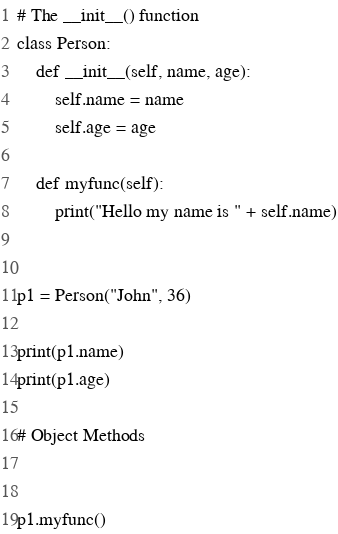<code> <loc_0><loc_0><loc_500><loc_500><_Python_># The __init__() function
class Person:
    def __init__(self, name, age):
        self.name = name
        self.age = age

    def myfunc(self):
        print("Hello my name is " + self.name)


p1 = Person("John", 36)

print(p1.name)
print(p1.age)

# Object Methods


p1.myfunc()
</code> 